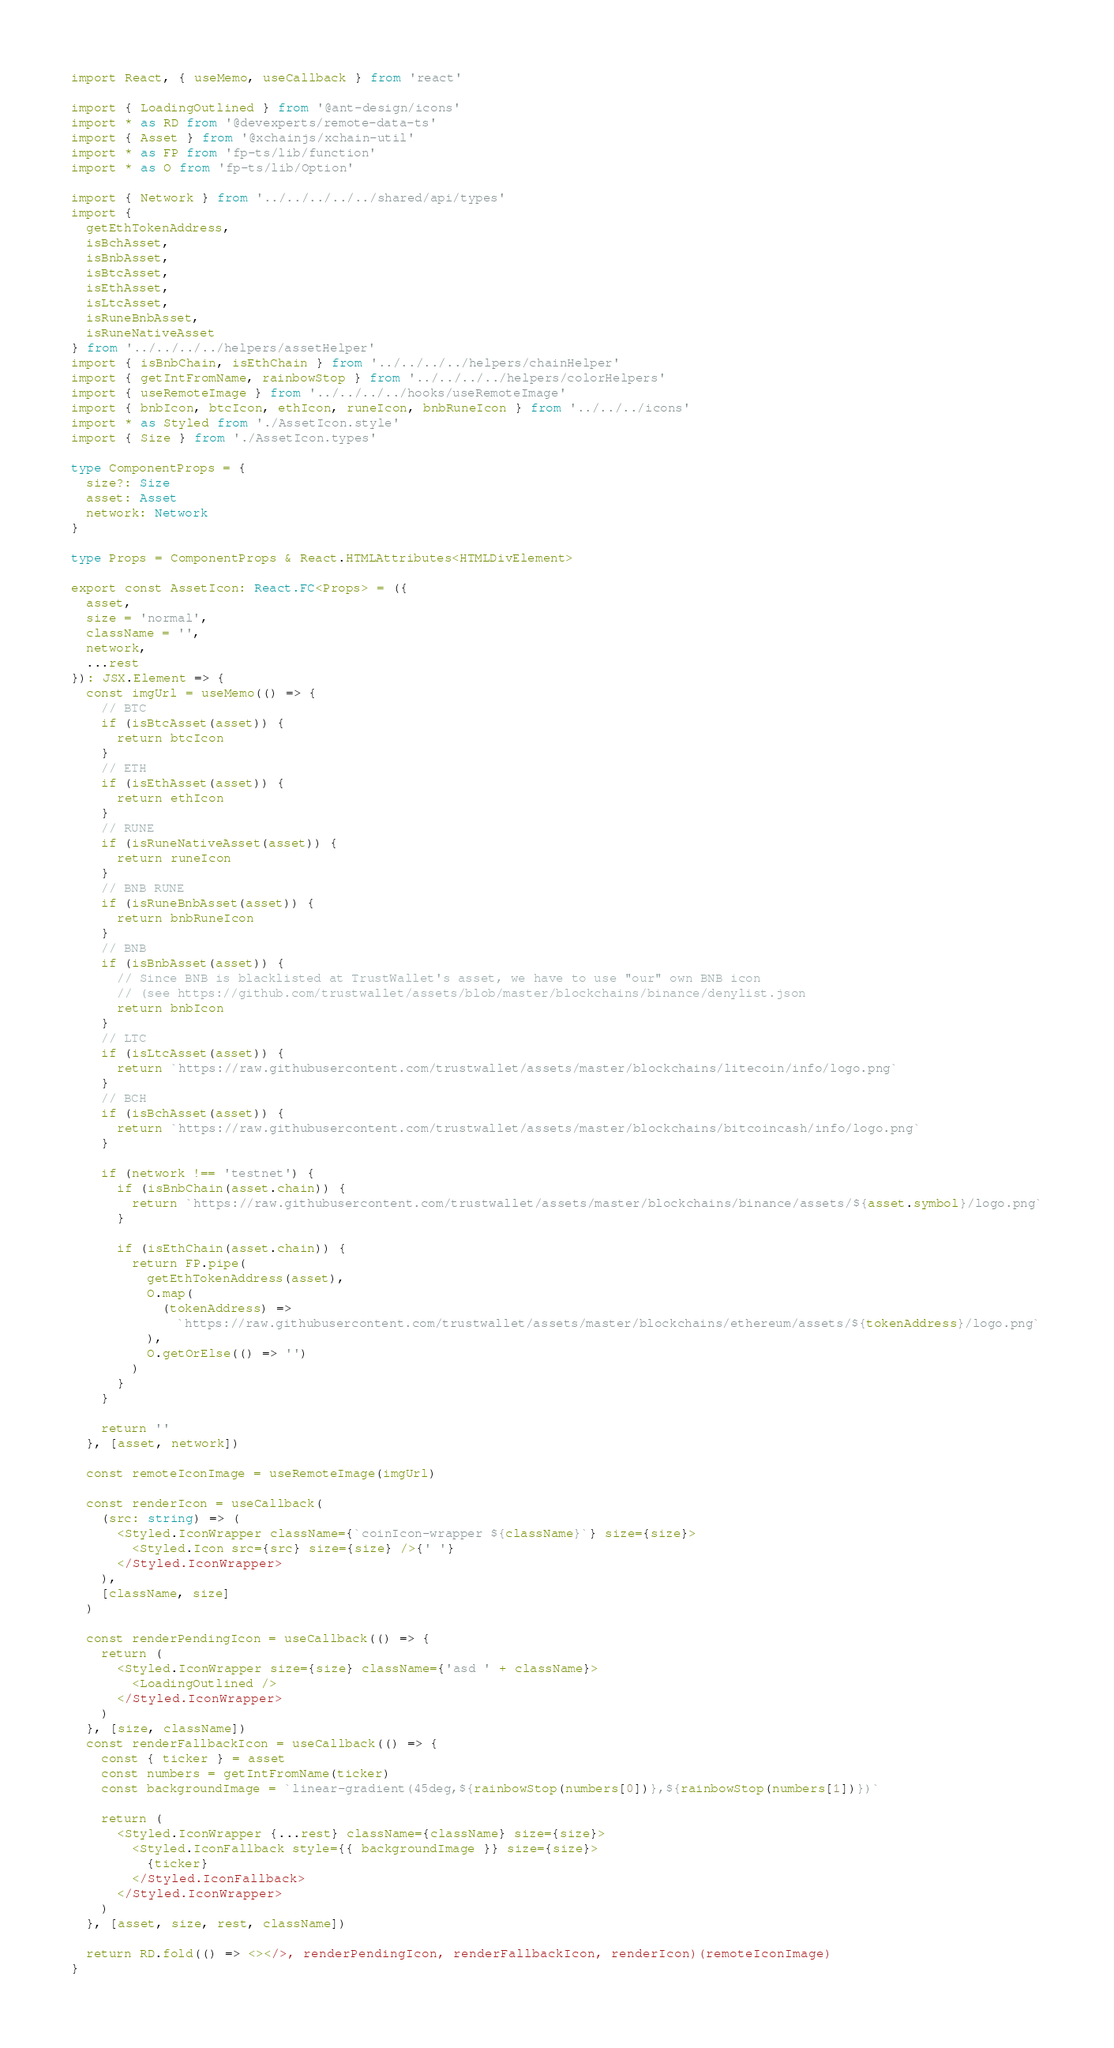Convert code to text. <code><loc_0><loc_0><loc_500><loc_500><_TypeScript_>import React, { useMemo, useCallback } from 'react'

import { LoadingOutlined } from '@ant-design/icons'
import * as RD from '@devexperts/remote-data-ts'
import { Asset } from '@xchainjs/xchain-util'
import * as FP from 'fp-ts/lib/function'
import * as O from 'fp-ts/lib/Option'

import { Network } from '../../../../../shared/api/types'
import {
  getEthTokenAddress,
  isBchAsset,
  isBnbAsset,
  isBtcAsset,
  isEthAsset,
  isLtcAsset,
  isRuneBnbAsset,
  isRuneNativeAsset
} from '../../../../helpers/assetHelper'
import { isBnbChain, isEthChain } from '../../../../helpers/chainHelper'
import { getIntFromName, rainbowStop } from '../../../../helpers/colorHelpers'
import { useRemoteImage } from '../../../../hooks/useRemoteImage'
import { bnbIcon, btcIcon, ethIcon, runeIcon, bnbRuneIcon } from '../../../icons'
import * as Styled from './AssetIcon.style'
import { Size } from './AssetIcon.types'

type ComponentProps = {
  size?: Size
  asset: Asset
  network: Network
}

type Props = ComponentProps & React.HTMLAttributes<HTMLDivElement>

export const AssetIcon: React.FC<Props> = ({
  asset,
  size = 'normal',
  className = '',
  network,
  ...rest
}): JSX.Element => {
  const imgUrl = useMemo(() => {
    // BTC
    if (isBtcAsset(asset)) {
      return btcIcon
    }
    // ETH
    if (isEthAsset(asset)) {
      return ethIcon
    }
    // RUNE
    if (isRuneNativeAsset(asset)) {
      return runeIcon
    }
    // BNB RUNE
    if (isRuneBnbAsset(asset)) {
      return bnbRuneIcon
    }
    // BNB
    if (isBnbAsset(asset)) {
      // Since BNB is blacklisted at TrustWallet's asset, we have to use "our" own BNB icon
      // (see https://github.com/trustwallet/assets/blob/master/blockchains/binance/denylist.json
      return bnbIcon
    }
    // LTC
    if (isLtcAsset(asset)) {
      return `https://raw.githubusercontent.com/trustwallet/assets/master/blockchains/litecoin/info/logo.png`
    }
    // BCH
    if (isBchAsset(asset)) {
      return `https://raw.githubusercontent.com/trustwallet/assets/master/blockchains/bitcoincash/info/logo.png`
    }

    if (network !== 'testnet') {
      if (isBnbChain(asset.chain)) {
        return `https://raw.githubusercontent.com/trustwallet/assets/master/blockchains/binance/assets/${asset.symbol}/logo.png`
      }

      if (isEthChain(asset.chain)) {
        return FP.pipe(
          getEthTokenAddress(asset),
          O.map(
            (tokenAddress) =>
              `https://raw.githubusercontent.com/trustwallet/assets/master/blockchains/ethereum/assets/${tokenAddress}/logo.png`
          ),
          O.getOrElse(() => '')
        )
      }
    }

    return ''
  }, [asset, network])

  const remoteIconImage = useRemoteImage(imgUrl)

  const renderIcon = useCallback(
    (src: string) => (
      <Styled.IconWrapper className={`coinIcon-wrapper ${className}`} size={size}>
        <Styled.Icon src={src} size={size} />{' '}
      </Styled.IconWrapper>
    ),
    [className, size]
  )

  const renderPendingIcon = useCallback(() => {
    return (
      <Styled.IconWrapper size={size} className={'asd ' + className}>
        <LoadingOutlined />
      </Styled.IconWrapper>
    )
  }, [size, className])
  const renderFallbackIcon = useCallback(() => {
    const { ticker } = asset
    const numbers = getIntFromName(ticker)
    const backgroundImage = `linear-gradient(45deg,${rainbowStop(numbers[0])},${rainbowStop(numbers[1])})`

    return (
      <Styled.IconWrapper {...rest} className={className} size={size}>
        <Styled.IconFallback style={{ backgroundImage }} size={size}>
          {ticker}
        </Styled.IconFallback>
      </Styled.IconWrapper>
    )
  }, [asset, size, rest, className])

  return RD.fold(() => <></>, renderPendingIcon, renderFallbackIcon, renderIcon)(remoteIconImage)
}
</code> 